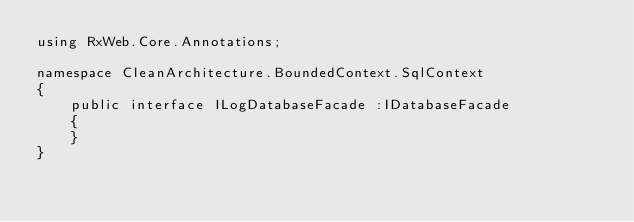<code> <loc_0><loc_0><loc_500><loc_500><_C#_>using RxWeb.Core.Annotations;

namespace CleanArchitecture.BoundedContext.SqlContext
{
    public interface ILogDatabaseFacade :IDatabaseFacade
    {
    }
}</code> 